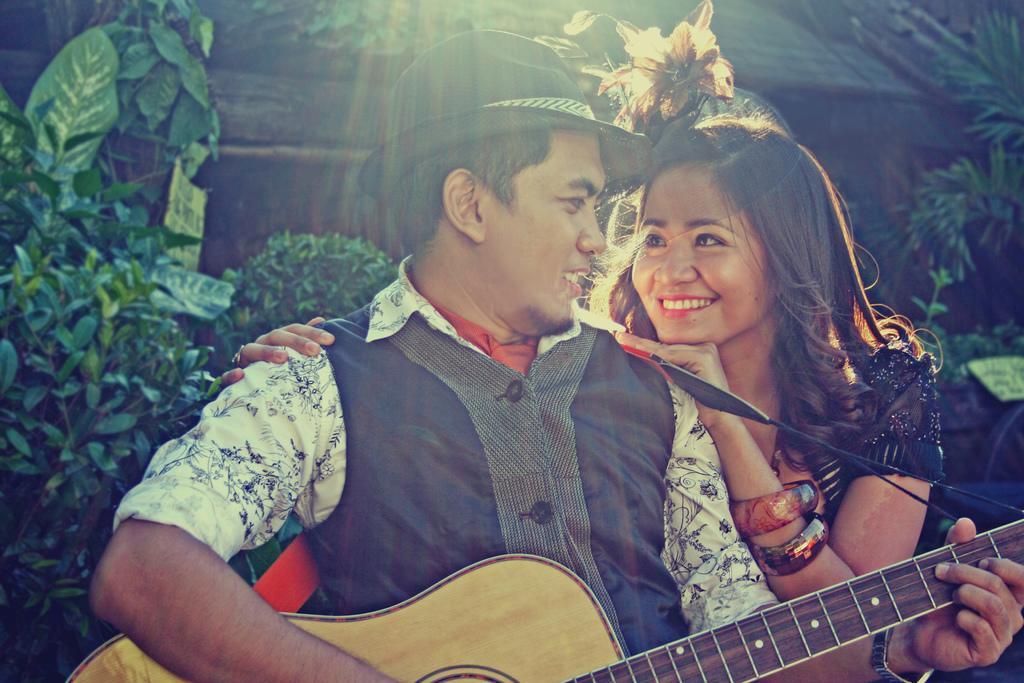Please provide a concise description of this image. A man with black jacket and white shirt is playing a guitar. He is wearing a black color cap on his head. Beside him there is a girl with black dress. She is standing. And she is smiling. In the background there are some trees. 